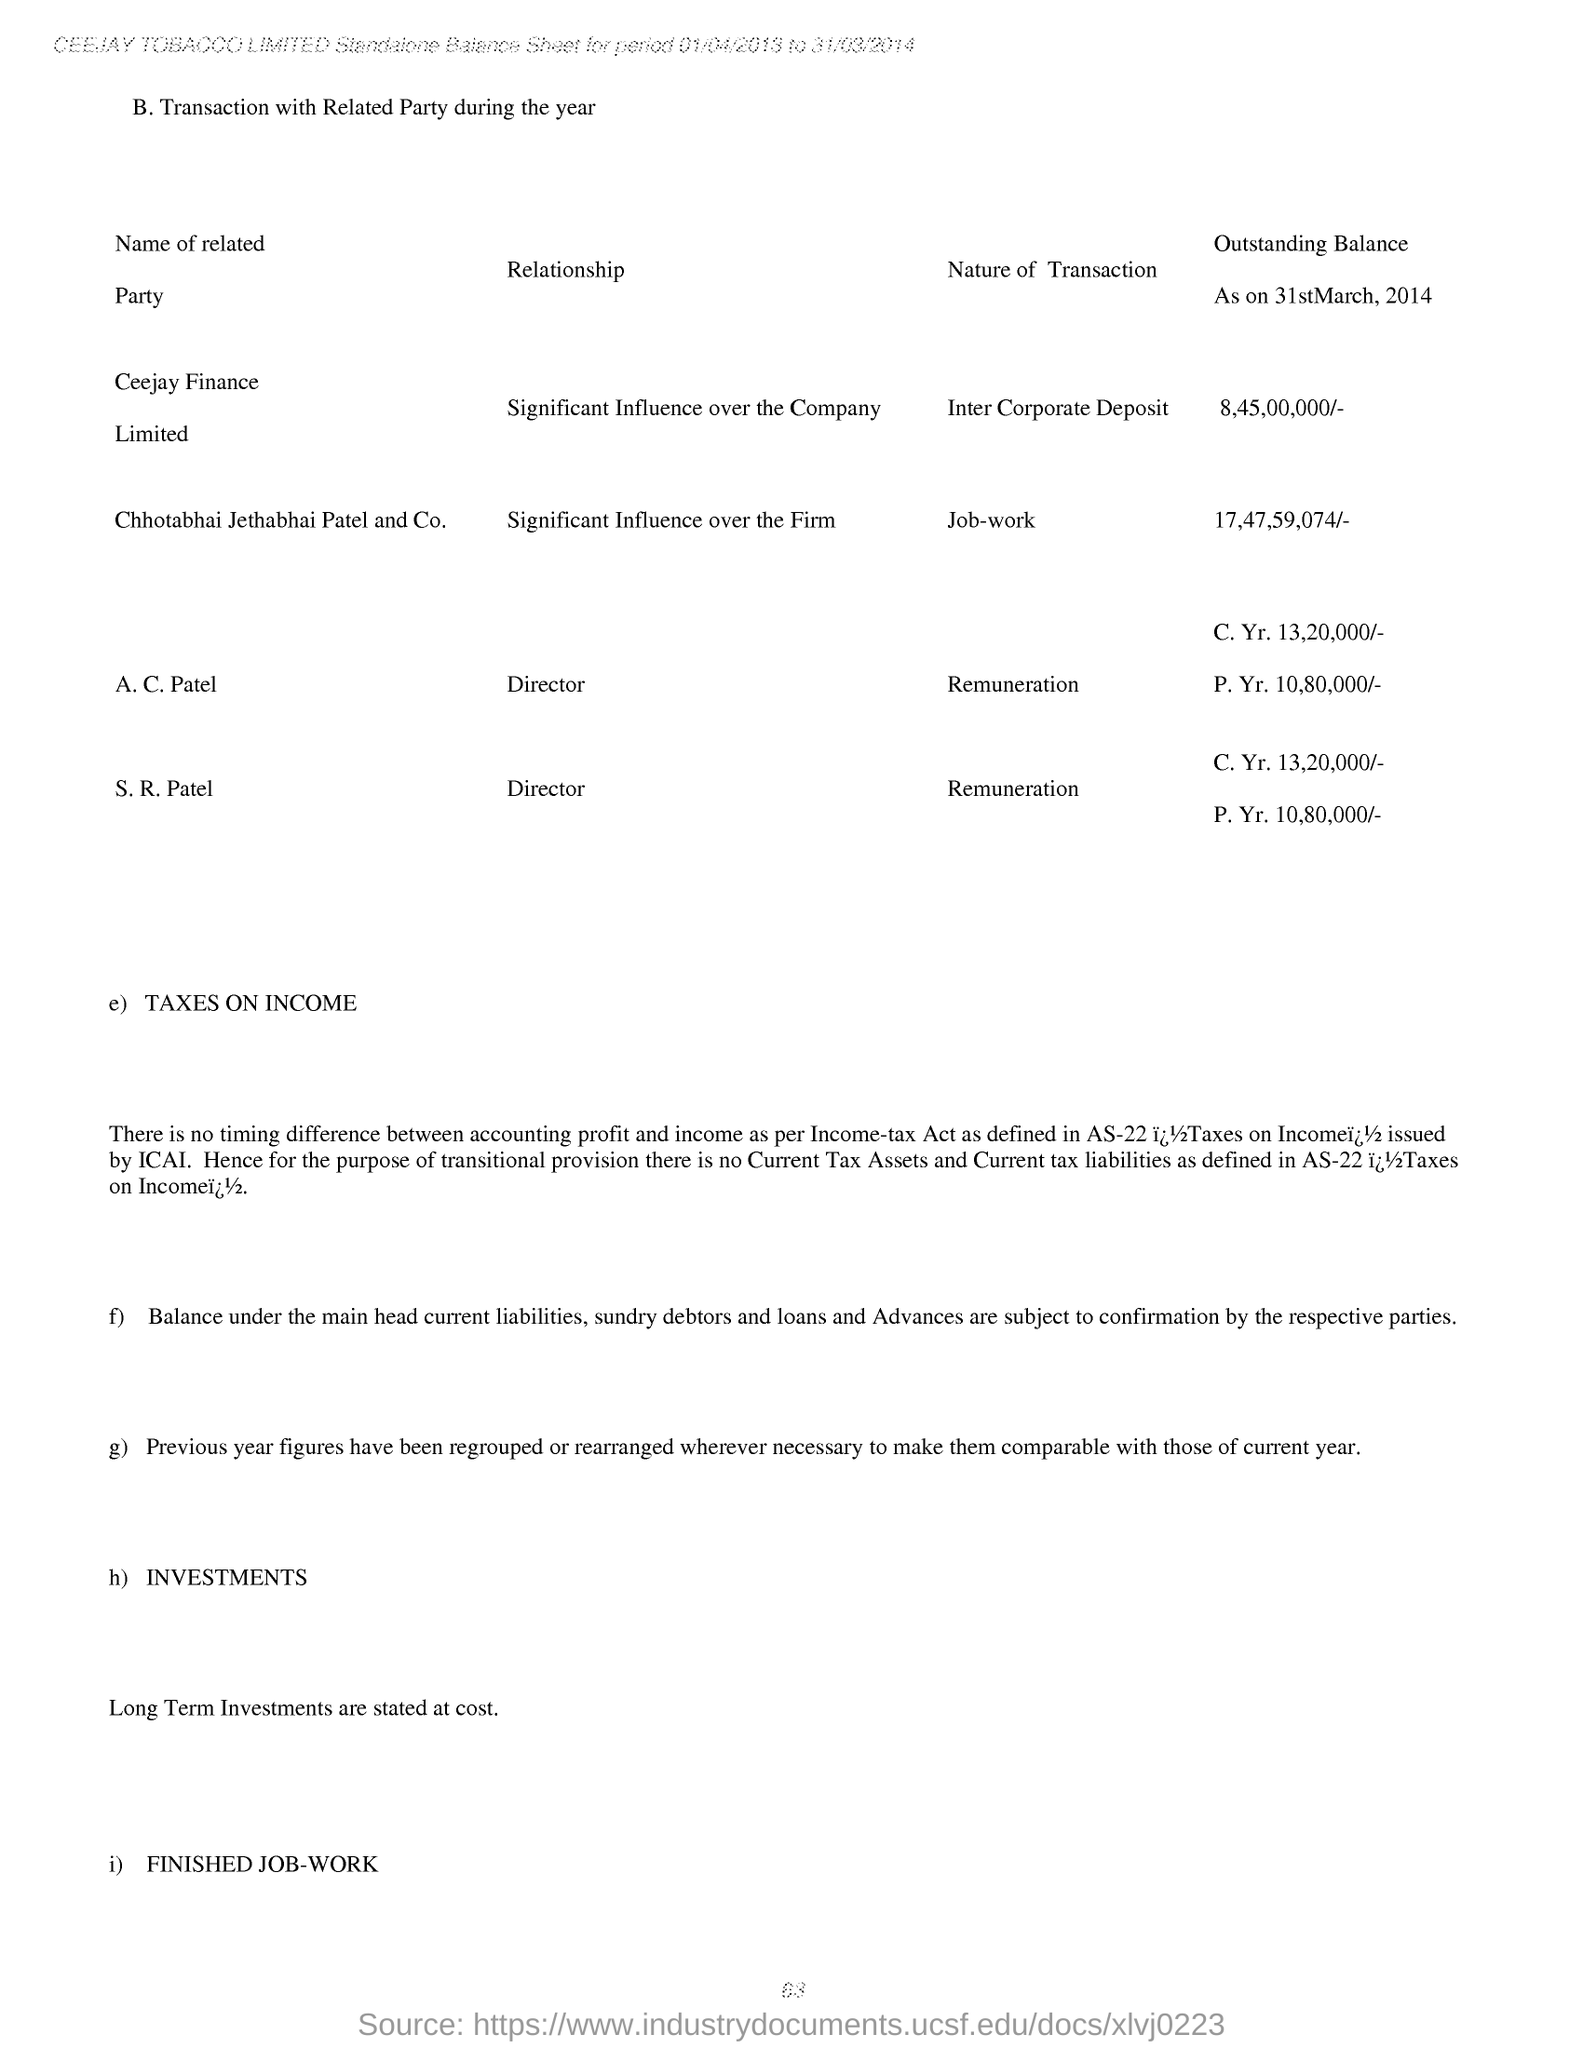Specify some key components in this picture. S. R. Patel's designation is Director. A. C. Patel's designation is Director. The outstanding balance as on 31st March, 2014 for Ceejay Finance Limited was 8,45,00,000/-. The transaction mentioned for Ceejay Finance Limited is an Inter Corporate Deposit. As of March 31, 2014, the outstanding balance for Chhotabhai Jethabhai Patel and Co. was 17,47,59,074 rupees. 